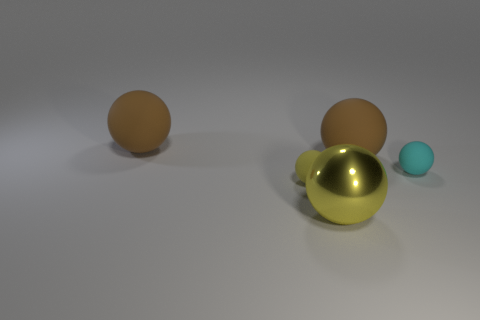Subtract all cyan matte balls. How many balls are left? 4 Subtract all cyan balls. How many balls are left? 4 Subtract all gray balls. Subtract all gray blocks. How many balls are left? 5 Add 3 tiny blue blocks. How many objects exist? 8 Subtract 0 blue balls. How many objects are left? 5 Subtract all spheres. Subtract all large purple rubber blocks. How many objects are left? 0 Add 1 big brown objects. How many big brown objects are left? 3 Add 1 big purple things. How many big purple things exist? 1 